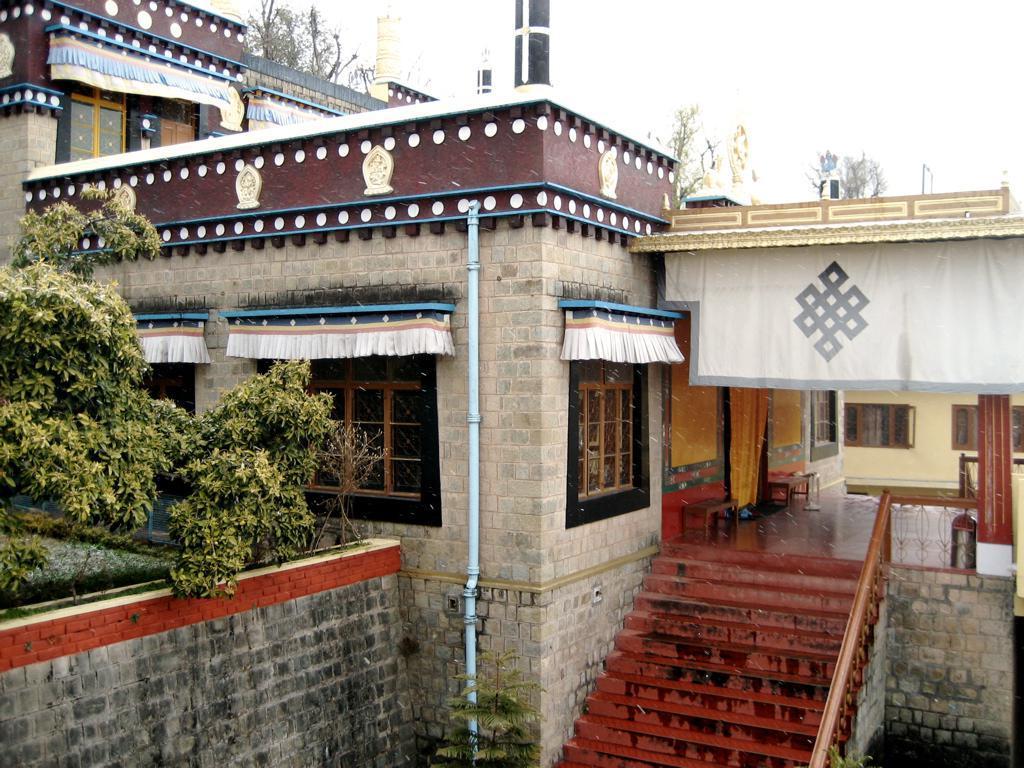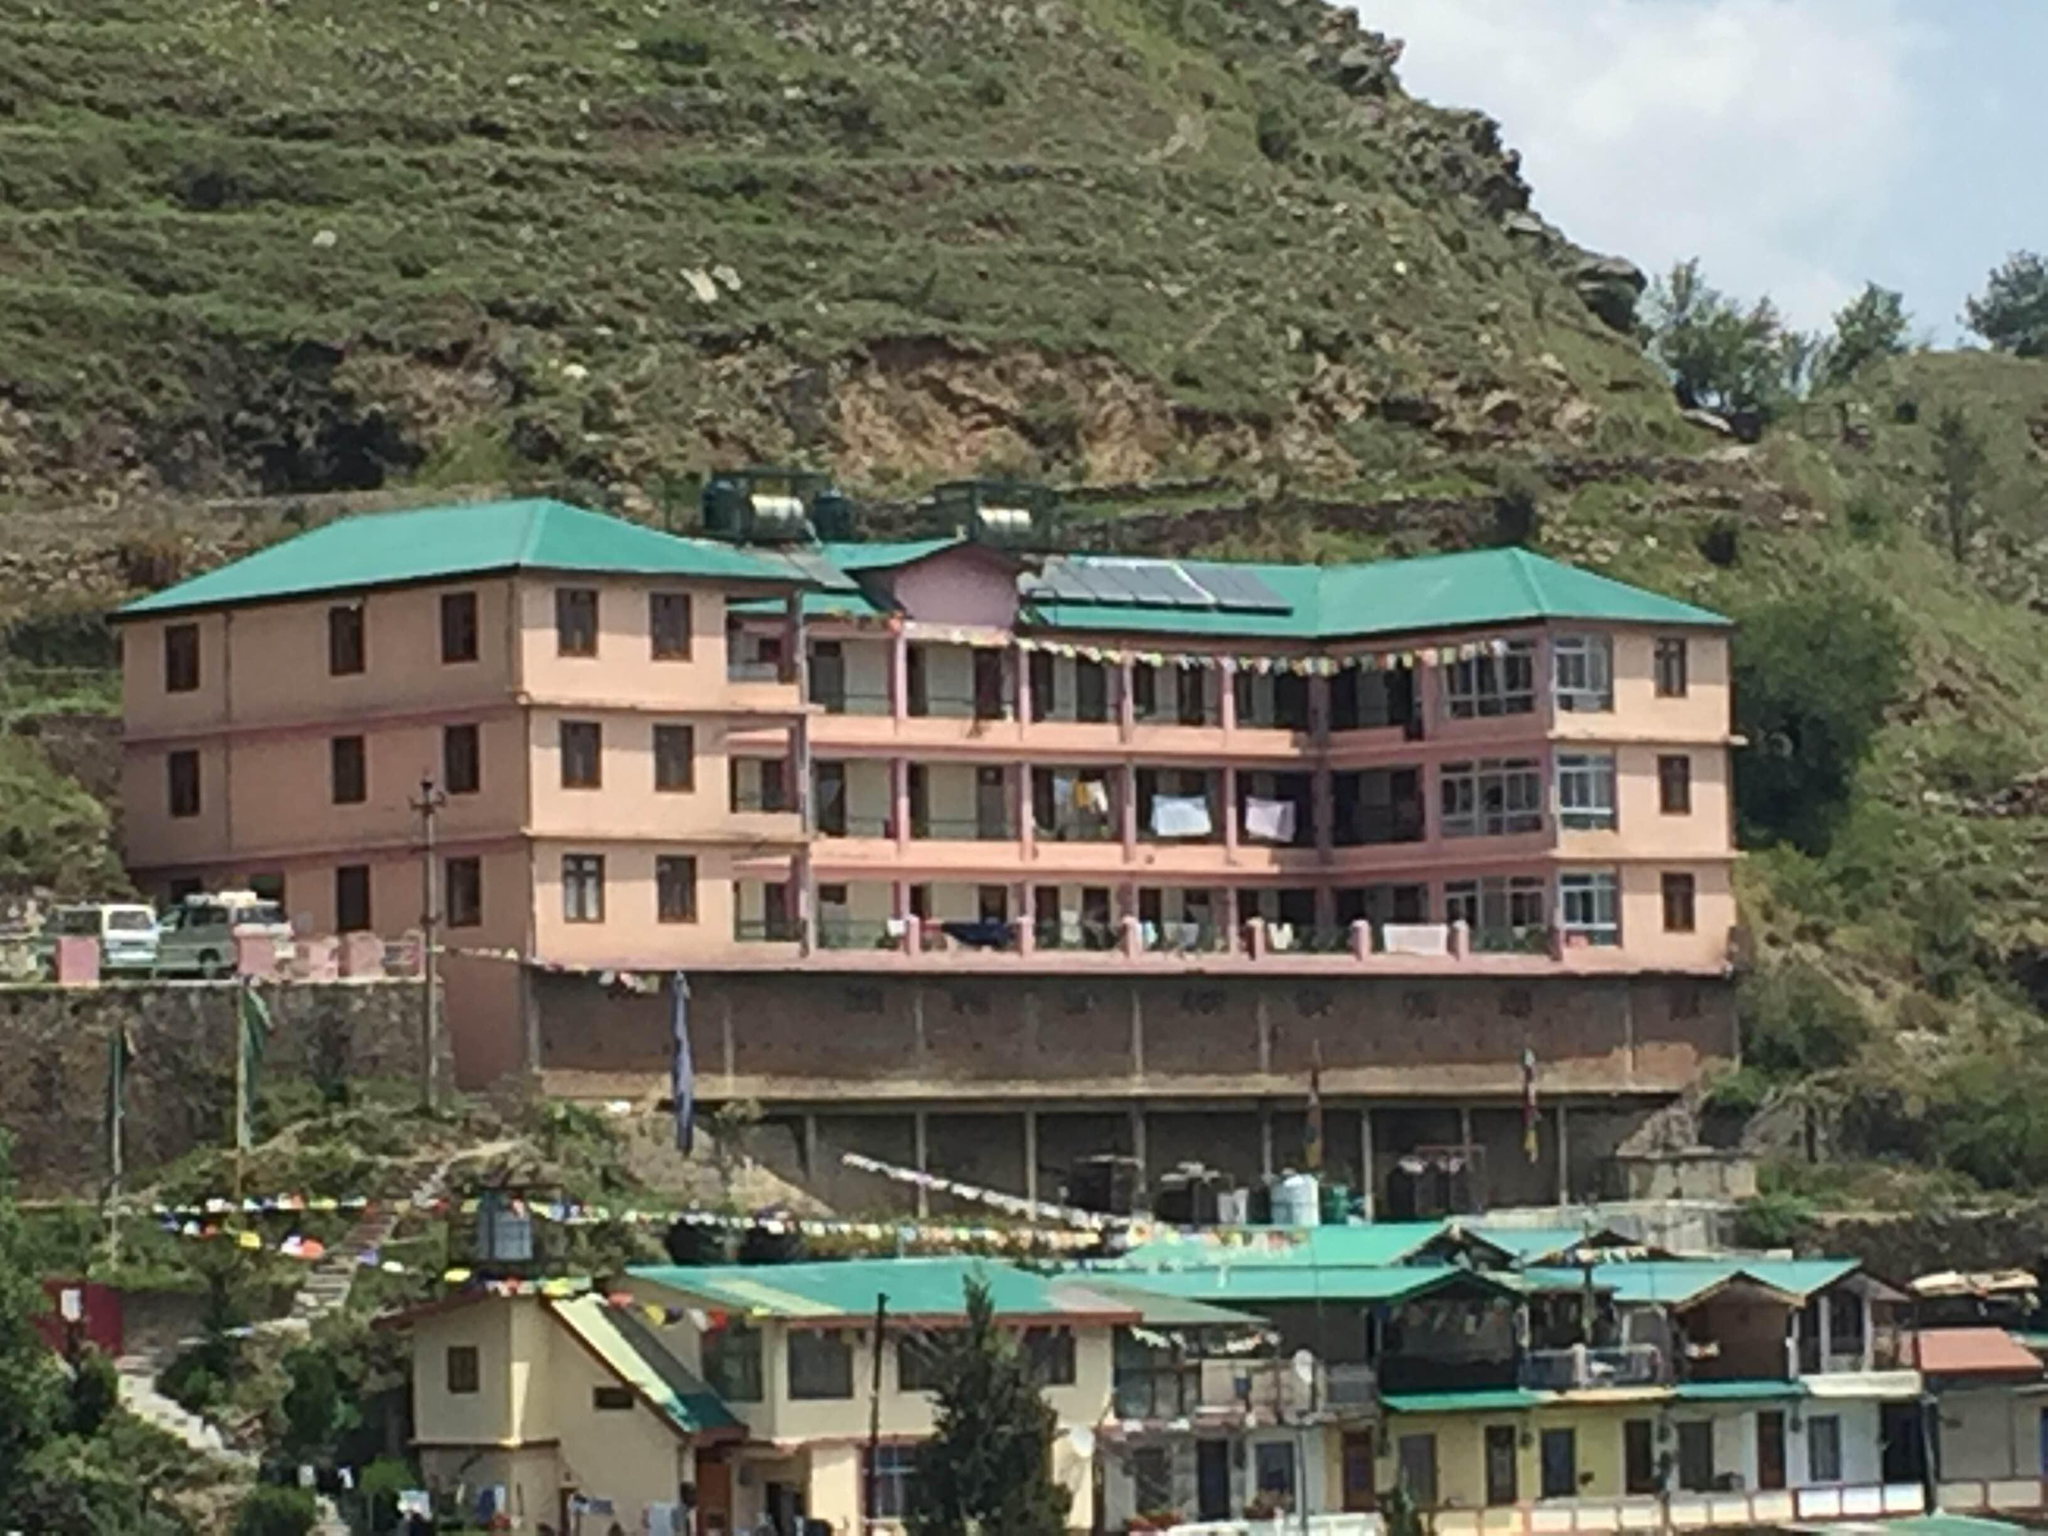The first image is the image on the left, the second image is the image on the right. Given the left and right images, does the statement "The roof is pink on the structure in the image on the left." hold true? Answer yes or no. No. 